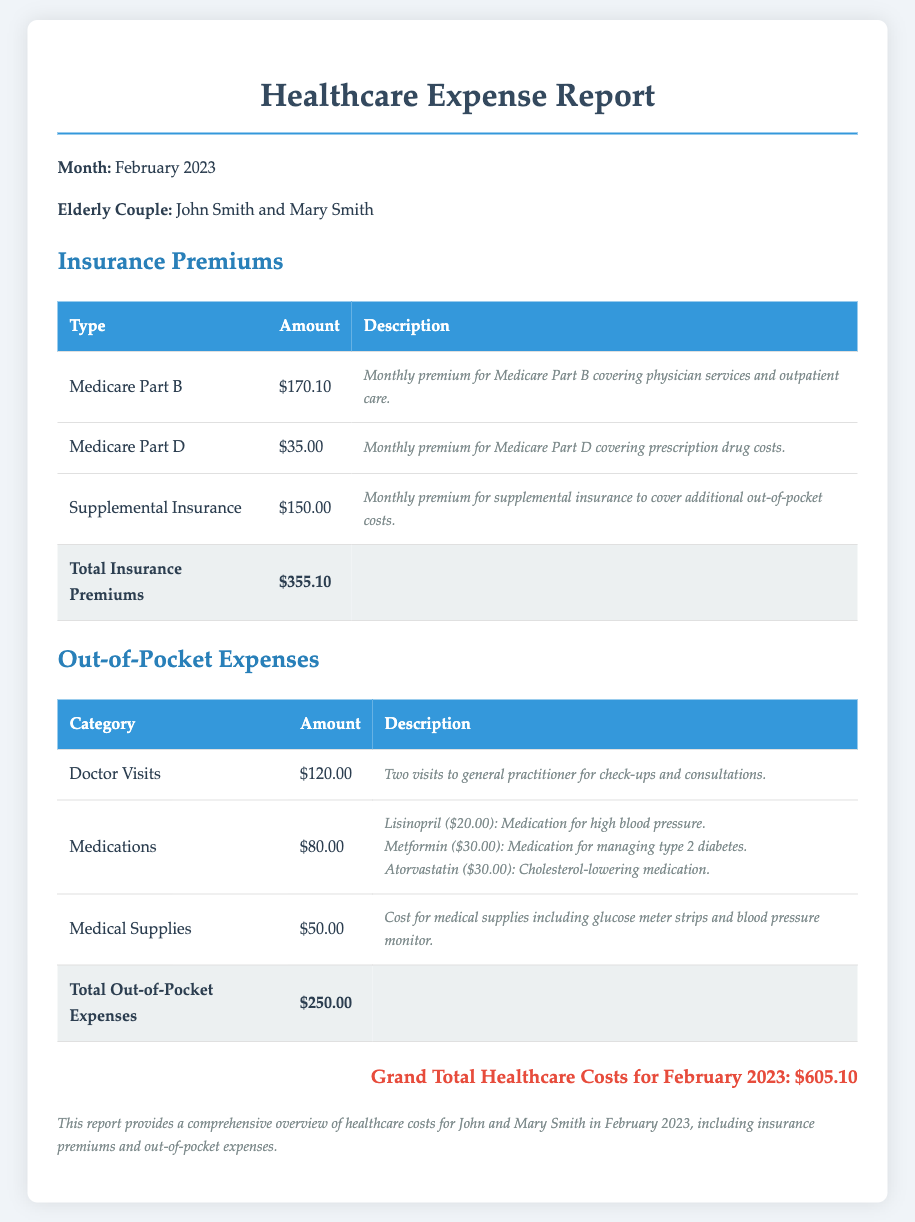What is the total amount for Medicare Part B premium? The Medicare Part B premium amount is clearly listed in the document, which is $170.10.
Answer: $170.10 What is the total for all insurance premiums? The total insurance premiums are calculated by adding the individual premiums: $170.10 + $35.00 + $150.00, which equals $355.10.
Answer: $355.10 How much was spent on medications? The document specifies the amount spent on medications, which is $80.00.
Answer: $80.00 What was the total for out-of-pocket expenses? The total out-of-pocket expenses can be found by summing the different categories listed, which is $120.00 + $80.00 + $50.00 = $250.00.
Answer: $250.00 What is the grand total of healthcare costs? The grand total is indicated at the bottom of the report, which adds up all expenses to $605.10.
Answer: $605.10 How many doctor visits are included in the report? The document states there were two visits to the general practitioner for check-ups and consultations.
Answer: Two What medications are mentioned in the report? The report lists Lisinopril, Metformin, and Atorvastatin as the medications included in out-of-pocket expenses.
Answer: Lisinopril, Metformin, Atorvastatin What type of report is this document? The document is specifically a healthcare expense report for a given month, which is detailed and structured accordingly.
Answer: Healthcare Expense Report Who are the elderly couple referenced in the document? The names mentioned as the elderly couple in the document are John Smith and Mary Smith.
Answer: John Smith and Mary Smith 